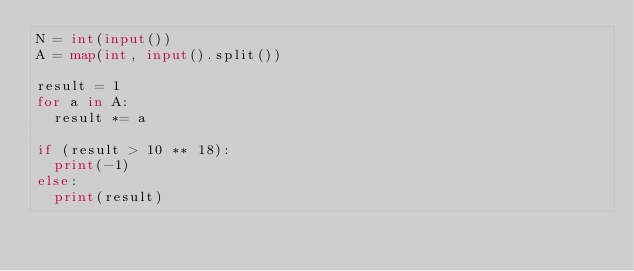Convert code to text. <code><loc_0><loc_0><loc_500><loc_500><_Python_>N = int(input())
A = map(int, input().split())

result = 1
for a in A:
  result *= a

if (result > 10 ** 18):
  print(-1)
else:
  print(result)</code> 